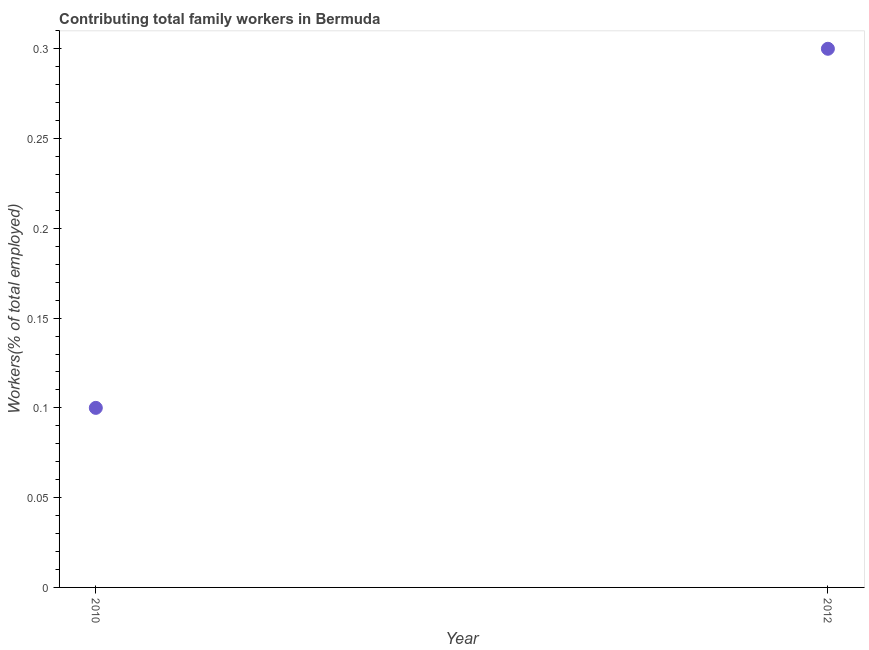What is the contributing family workers in 2012?
Keep it short and to the point. 0.3. Across all years, what is the maximum contributing family workers?
Your response must be concise. 0.3. Across all years, what is the minimum contributing family workers?
Your answer should be very brief. 0.1. In which year was the contributing family workers maximum?
Offer a very short reply. 2012. In which year was the contributing family workers minimum?
Provide a short and direct response. 2010. What is the sum of the contributing family workers?
Your response must be concise. 0.4. What is the difference between the contributing family workers in 2010 and 2012?
Give a very brief answer. -0.2. What is the average contributing family workers per year?
Your response must be concise. 0.2. What is the median contributing family workers?
Offer a very short reply. 0.2. Do a majority of the years between 2010 and 2012 (inclusive) have contributing family workers greater than 0.02 %?
Keep it short and to the point. Yes. What is the ratio of the contributing family workers in 2010 to that in 2012?
Provide a short and direct response. 0.33. How many dotlines are there?
Your answer should be compact. 1. How many years are there in the graph?
Ensure brevity in your answer.  2. Are the values on the major ticks of Y-axis written in scientific E-notation?
Make the answer very short. No. What is the title of the graph?
Offer a very short reply. Contributing total family workers in Bermuda. What is the label or title of the X-axis?
Your answer should be very brief. Year. What is the label or title of the Y-axis?
Your answer should be very brief. Workers(% of total employed). What is the Workers(% of total employed) in 2010?
Keep it short and to the point. 0.1. What is the Workers(% of total employed) in 2012?
Offer a very short reply. 0.3. What is the ratio of the Workers(% of total employed) in 2010 to that in 2012?
Keep it short and to the point. 0.33. 